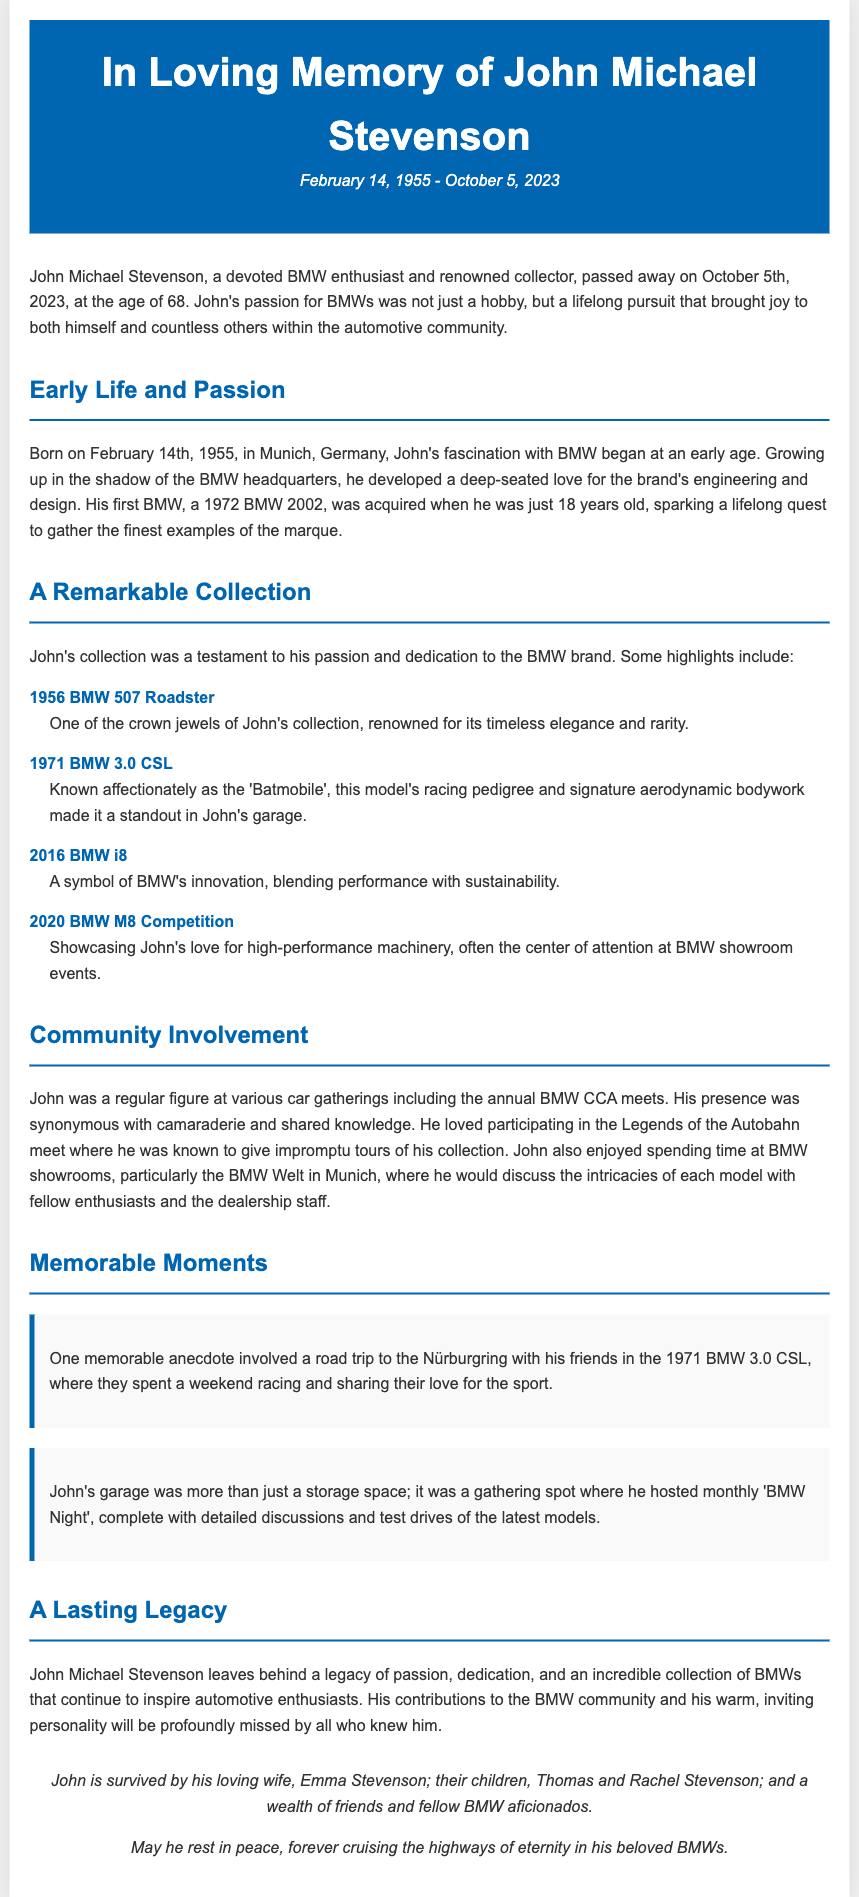what date did John Michael Stevenson pass away? The date of John Michael Stevenson's passing is clearly stated in the document.
Answer: October 5, 2023 what was John's first BMW model? The document mentions John's first BMW model, which he acquired at the age of 18.
Answer: 1972 BMW 2002 how many children did John leave behind? The number of children that John is stated to have in the document is mentioned in the final paragraph.
Answer: two which model is known as the 'Batmobile'? This title is associated with a specific model in John's collection that is highlighted in the document.
Answer: 1971 BMW 3.0 CSL what was John’s favorite BMW showroom to visit? The document specifies a particular BMW showroom that John enjoyed spending time at.
Answer: BMW Welt in Munich what event did John participate in annually? The document describes an annual event that John regularly attended, emphasizing his community involvement.
Answer: BMW CCA meets how did John contribute to the automotive community? The document outlines John’s involvement and the type of events he engaged in within the automotive community.
Answer: Hosting 'BMW Night' what was one memorable activity John did with friends? An anecdote in the document describes a specific activity that showcases John's passion for BMWs and his friendships.
Answer: Road trip to the Nürburgring what color was the header of the obituary? The color of the header is specified in the document, which is characteristic of the design.
Answer: blue 